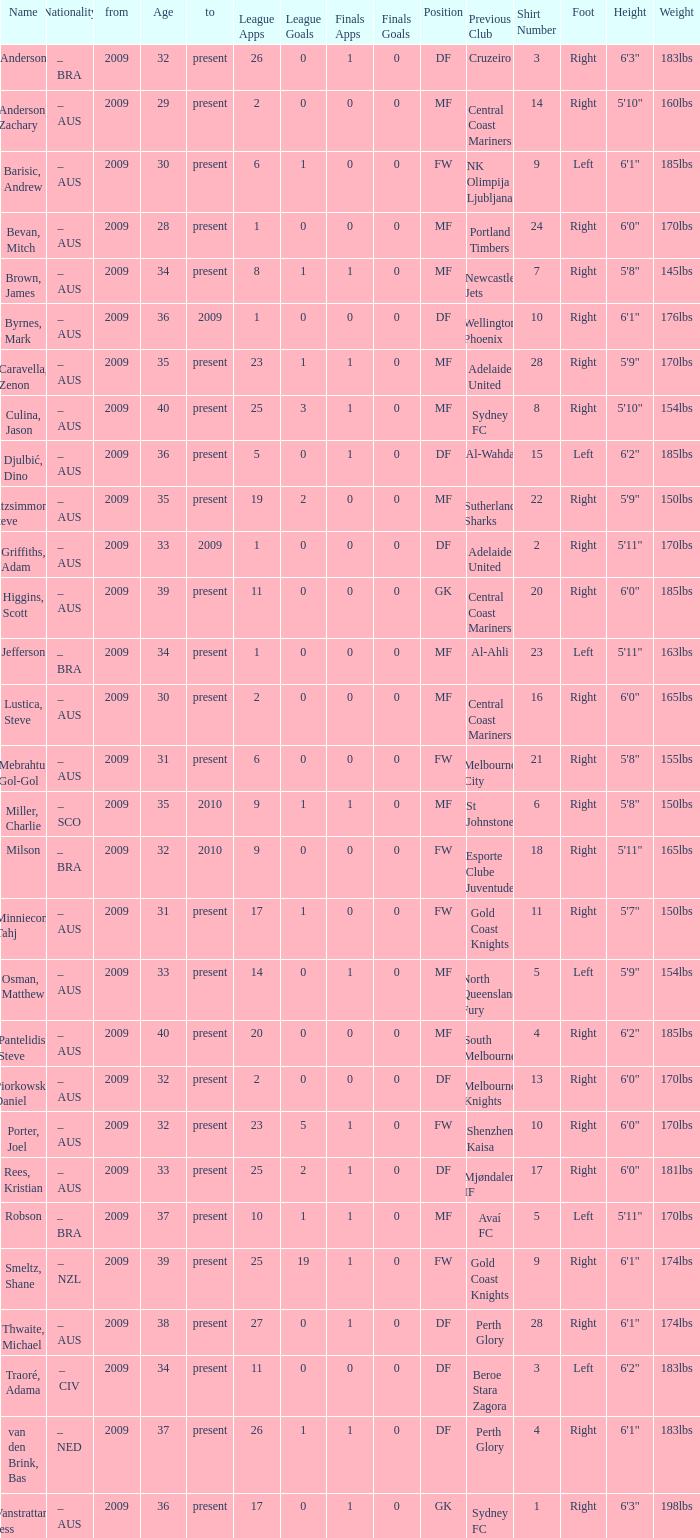Name the mosst finals apps 1.0. 